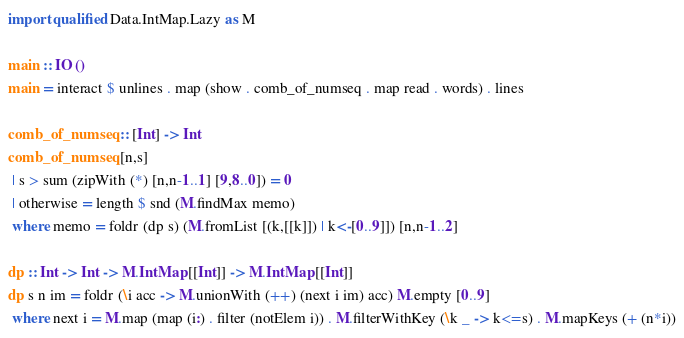<code> <loc_0><loc_0><loc_500><loc_500><_Haskell_>import qualified Data.IntMap.Lazy as M

main :: IO ()
main = interact $ unlines . map (show . comb_of_numseq . map read . words) . lines

comb_of_numseq :: [Int] -> Int
comb_of_numseq [n,s]
 | s > sum (zipWith (*) [n,n-1..1] [9,8..0]) = 0
 | otherwise = length $ snd (M.findMax memo)
 where memo = foldr (dp s) (M.fromList [(k,[[k]]) | k<-[0..9]]) [n,n-1..2]

dp :: Int -> Int -> M.IntMap [[Int]] -> M.IntMap [[Int]]
dp s n im = foldr (\i acc -> M.unionWith (++) (next i im) acc) M.empty [0..9]
 where next i = M.map (map (i:) . filter (notElem i)) . M.filterWithKey (\k _ -> k<=s) . M.mapKeys (+ (n*i))</code> 